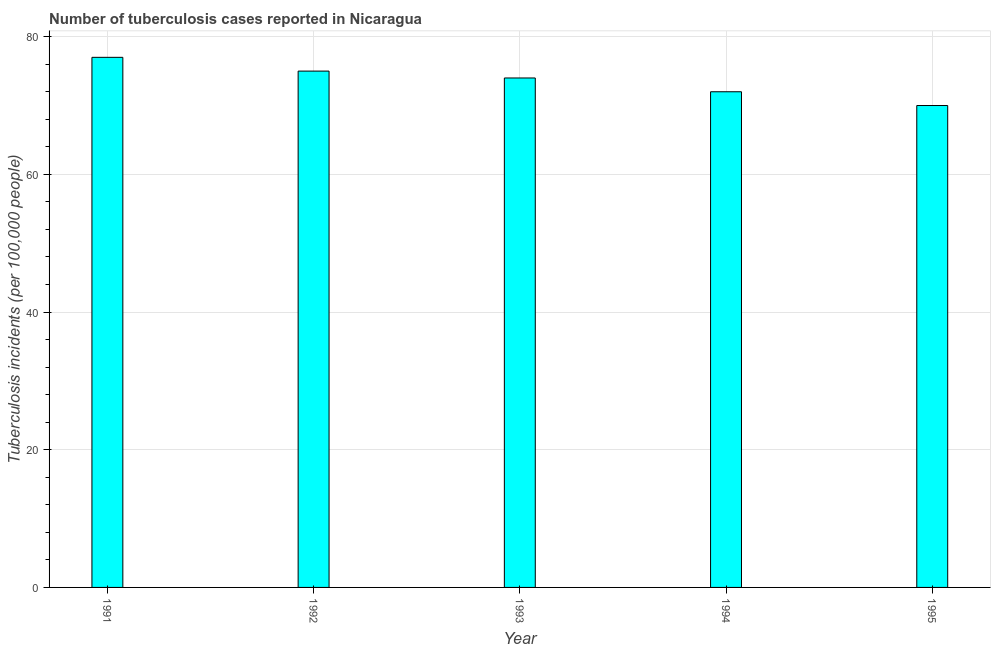Does the graph contain any zero values?
Your response must be concise. No. Does the graph contain grids?
Provide a succinct answer. Yes. What is the title of the graph?
Offer a terse response. Number of tuberculosis cases reported in Nicaragua. What is the label or title of the Y-axis?
Provide a succinct answer. Tuberculosis incidents (per 100,0 people). What is the number of tuberculosis incidents in 1991?
Make the answer very short. 77. Across all years, what is the maximum number of tuberculosis incidents?
Your response must be concise. 77. What is the sum of the number of tuberculosis incidents?
Your answer should be compact. 368. What is the median number of tuberculosis incidents?
Offer a very short reply. 74. What is the ratio of the number of tuberculosis incidents in 1991 to that in 1992?
Provide a succinct answer. 1.03. Is the number of tuberculosis incidents in 1992 less than that in 1993?
Ensure brevity in your answer.  No. Is the sum of the number of tuberculosis incidents in 1993 and 1994 greater than the maximum number of tuberculosis incidents across all years?
Make the answer very short. Yes. What is the difference between the highest and the lowest number of tuberculosis incidents?
Give a very brief answer. 7. In how many years, is the number of tuberculosis incidents greater than the average number of tuberculosis incidents taken over all years?
Offer a very short reply. 3. How many bars are there?
Your response must be concise. 5. How many years are there in the graph?
Give a very brief answer. 5. Are the values on the major ticks of Y-axis written in scientific E-notation?
Provide a short and direct response. No. What is the Tuberculosis incidents (per 100,000 people) of 1991?
Keep it short and to the point. 77. What is the Tuberculosis incidents (per 100,000 people) in 1993?
Your answer should be very brief. 74. What is the Tuberculosis incidents (per 100,000 people) in 1994?
Provide a succinct answer. 72. What is the Tuberculosis incidents (per 100,000 people) in 1995?
Keep it short and to the point. 70. What is the difference between the Tuberculosis incidents (per 100,000 people) in 1991 and 1992?
Give a very brief answer. 2. What is the difference between the Tuberculosis incidents (per 100,000 people) in 1991 and 1993?
Offer a terse response. 3. What is the difference between the Tuberculosis incidents (per 100,000 people) in 1991 and 1994?
Your response must be concise. 5. What is the difference between the Tuberculosis incidents (per 100,000 people) in 1992 and 1995?
Make the answer very short. 5. What is the difference between the Tuberculosis incidents (per 100,000 people) in 1993 and 1995?
Make the answer very short. 4. What is the difference between the Tuberculosis incidents (per 100,000 people) in 1994 and 1995?
Give a very brief answer. 2. What is the ratio of the Tuberculosis incidents (per 100,000 people) in 1991 to that in 1992?
Give a very brief answer. 1.03. What is the ratio of the Tuberculosis incidents (per 100,000 people) in 1991 to that in 1993?
Your answer should be compact. 1.04. What is the ratio of the Tuberculosis incidents (per 100,000 people) in 1991 to that in 1994?
Provide a succinct answer. 1.07. What is the ratio of the Tuberculosis incidents (per 100,000 people) in 1992 to that in 1993?
Offer a very short reply. 1.01. What is the ratio of the Tuberculosis incidents (per 100,000 people) in 1992 to that in 1994?
Give a very brief answer. 1.04. What is the ratio of the Tuberculosis incidents (per 100,000 people) in 1992 to that in 1995?
Your response must be concise. 1.07. What is the ratio of the Tuberculosis incidents (per 100,000 people) in 1993 to that in 1994?
Give a very brief answer. 1.03. What is the ratio of the Tuberculosis incidents (per 100,000 people) in 1993 to that in 1995?
Your response must be concise. 1.06. 